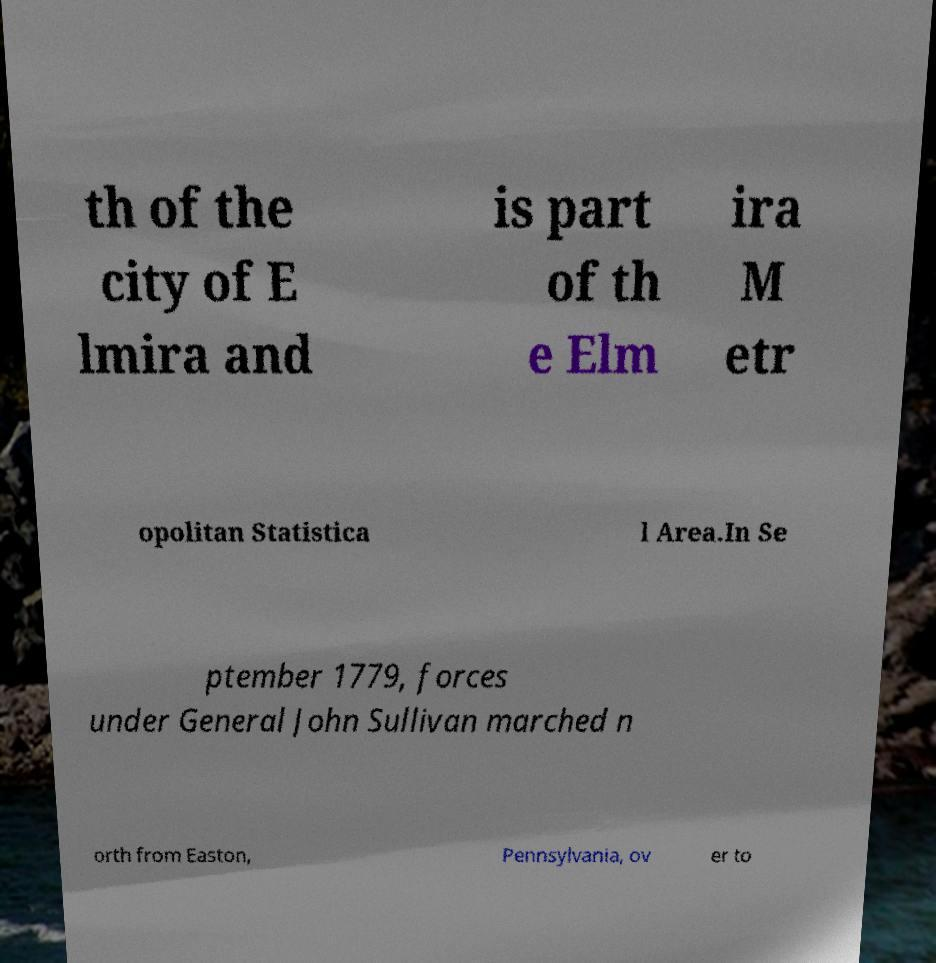Could you assist in decoding the text presented in this image and type it out clearly? th of the city of E lmira and is part of th e Elm ira M etr opolitan Statistica l Area.In Se ptember 1779, forces under General John Sullivan marched n orth from Easton, Pennsylvania, ov er to 